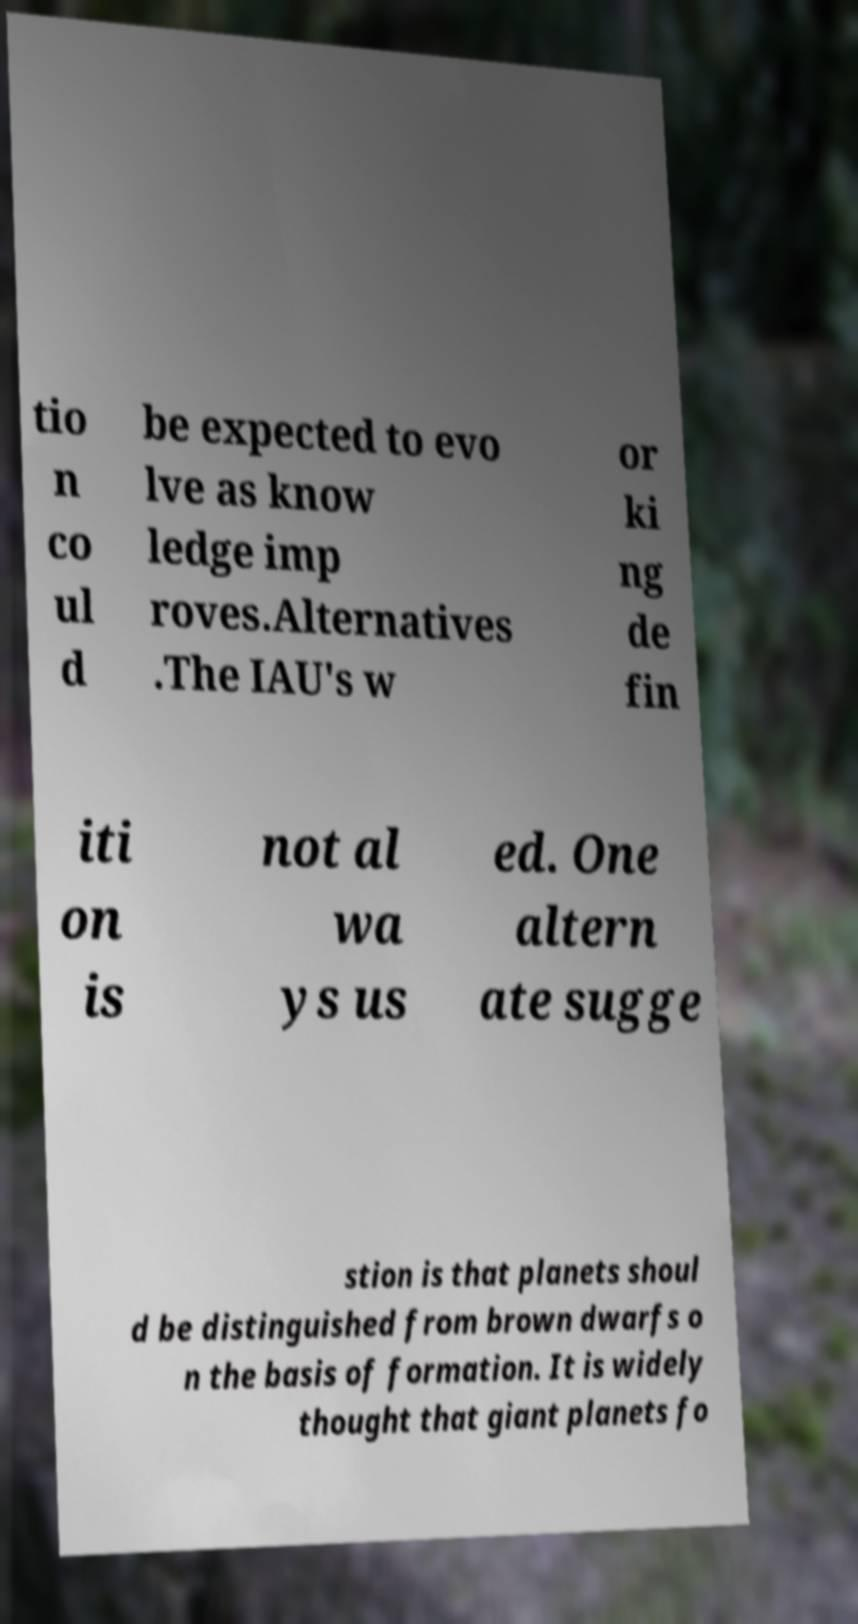There's text embedded in this image that I need extracted. Can you transcribe it verbatim? tio n co ul d be expected to evo lve as know ledge imp roves.Alternatives .The IAU's w or ki ng de fin iti on is not al wa ys us ed. One altern ate sugge stion is that planets shoul d be distinguished from brown dwarfs o n the basis of formation. It is widely thought that giant planets fo 